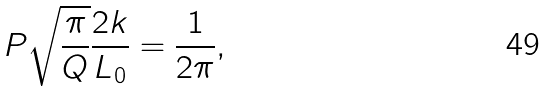<formula> <loc_0><loc_0><loc_500><loc_500>P \sqrt { \frac { \pi } { Q } } \frac { 2 k } { L _ { 0 } } = \frac { 1 } { 2 \pi } ,</formula> 